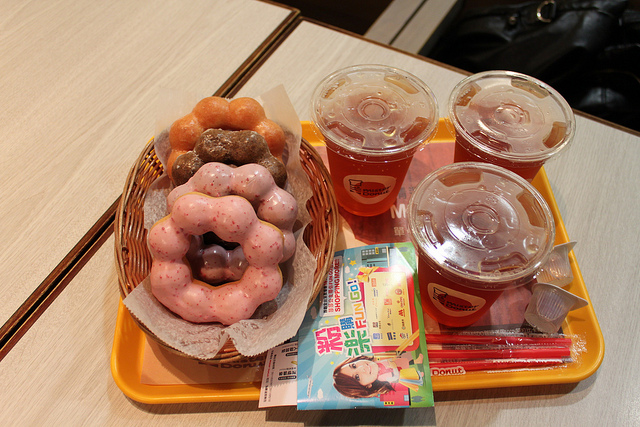Identify the text displayed in this image. FUNGO! Sonut SHOPPING M 